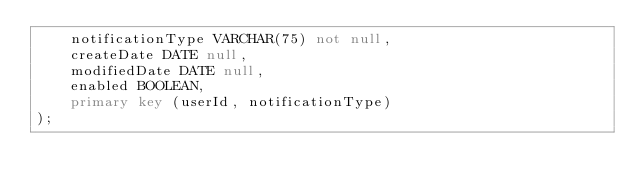<code> <loc_0><loc_0><loc_500><loc_500><_SQL_>	notificationType VARCHAR(75) not null,
	createDate DATE null,
	modifiedDate DATE null,
	enabled BOOLEAN,
	primary key (userId, notificationType)
);</code> 